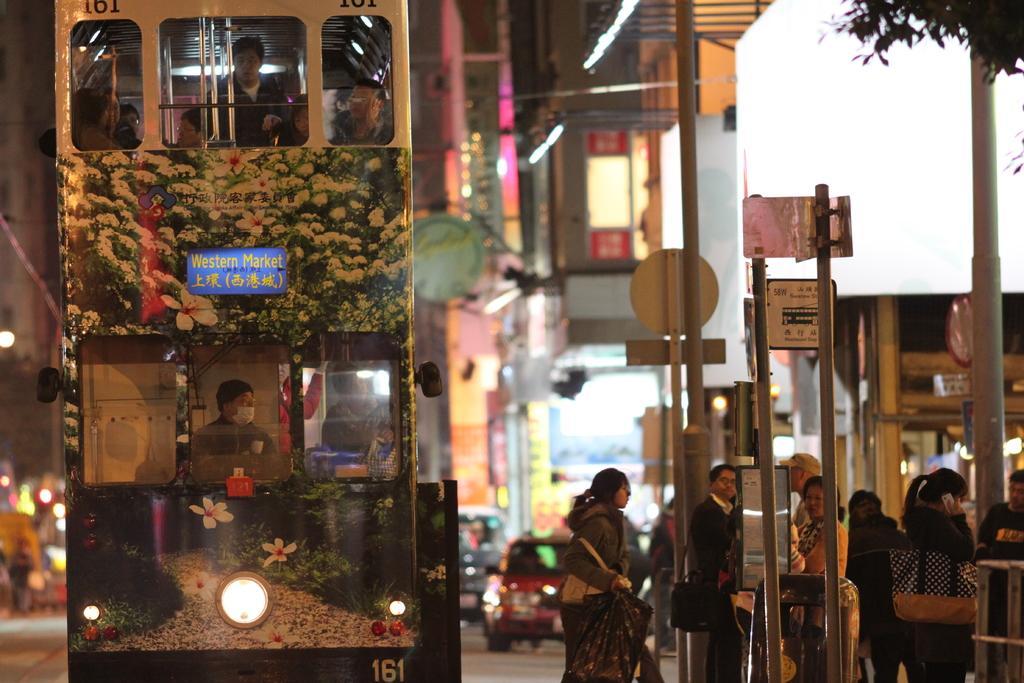Please provide a concise description of this image. In this picture on the right side we have people standing on the footpath near the signal. On the left side, we have a double Decker bus and other vehicles on the road 